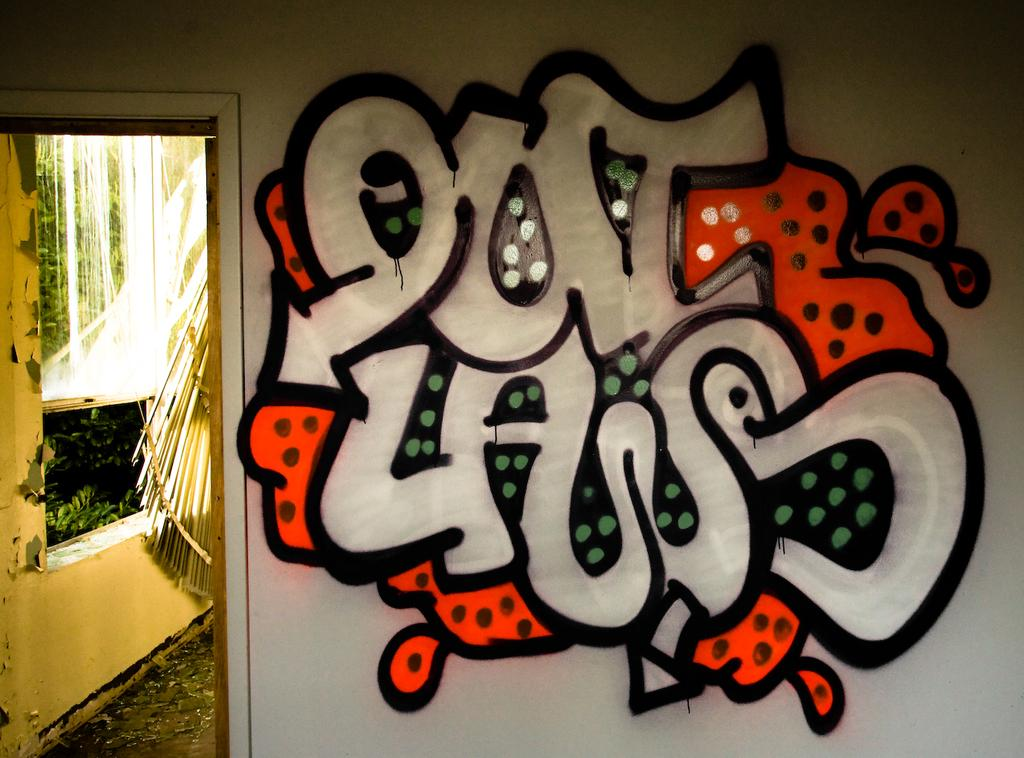What is on the wall in the image? There is a painting on the wall in the image. What can be seen in the background of the image? Leaves are visible in the background of the image. What else is present in the background of the image? There are objects present in the background of the image. Is there a net visible in the image? No, there is no net present in the image. What type of party is being held in the image? There is no party depicted in the image. 